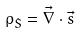<formula> <loc_0><loc_0><loc_500><loc_500>\rho _ { \dot { S } } = \vec { \nabla } \cdot \vec { s }</formula> 